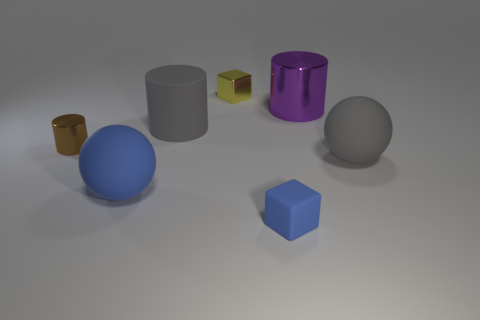Add 2 tiny yellow objects. How many objects exist? 9 Subtract all cylinders. How many objects are left? 4 Add 3 small blue blocks. How many small blue blocks are left? 4 Add 2 tiny metallic blocks. How many tiny metallic blocks exist? 3 Subtract 0 cyan cylinders. How many objects are left? 7 Subtract all large red metallic spheres. Subtract all large gray things. How many objects are left? 5 